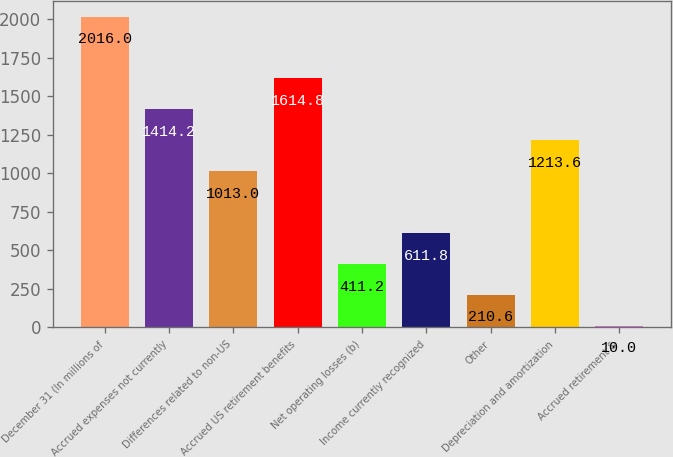Convert chart. <chart><loc_0><loc_0><loc_500><loc_500><bar_chart><fcel>December 31 (In millions of<fcel>Accrued expenses not currently<fcel>Differences related to non-US<fcel>Accrued US retirement benefits<fcel>Net operating losses (b)<fcel>Income currently recognized<fcel>Other<fcel>Depreciation and amortization<fcel>Accrued retirement &<nl><fcel>2016<fcel>1414.2<fcel>1013<fcel>1614.8<fcel>411.2<fcel>611.8<fcel>210.6<fcel>1213.6<fcel>10<nl></chart> 